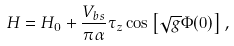Convert formula to latex. <formula><loc_0><loc_0><loc_500><loc_500>H = H _ { 0 } + \frac { V _ { b s } } { \pi \alpha } \tau _ { z } \cos \left [ \sqrt { g } \Phi ( 0 ) \right ] ,</formula> 